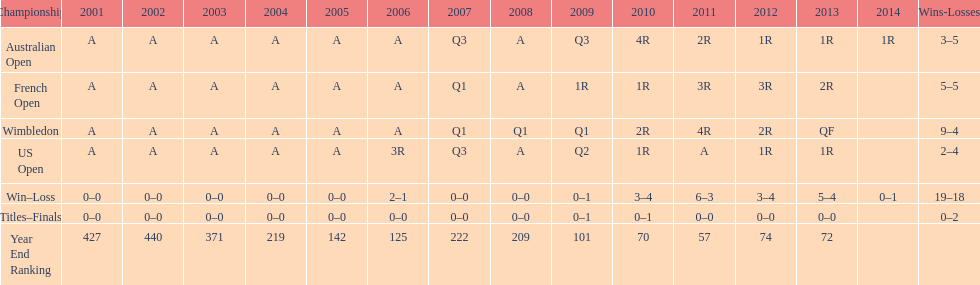What was the total number of matches played from 2001 to 2014? 37. 